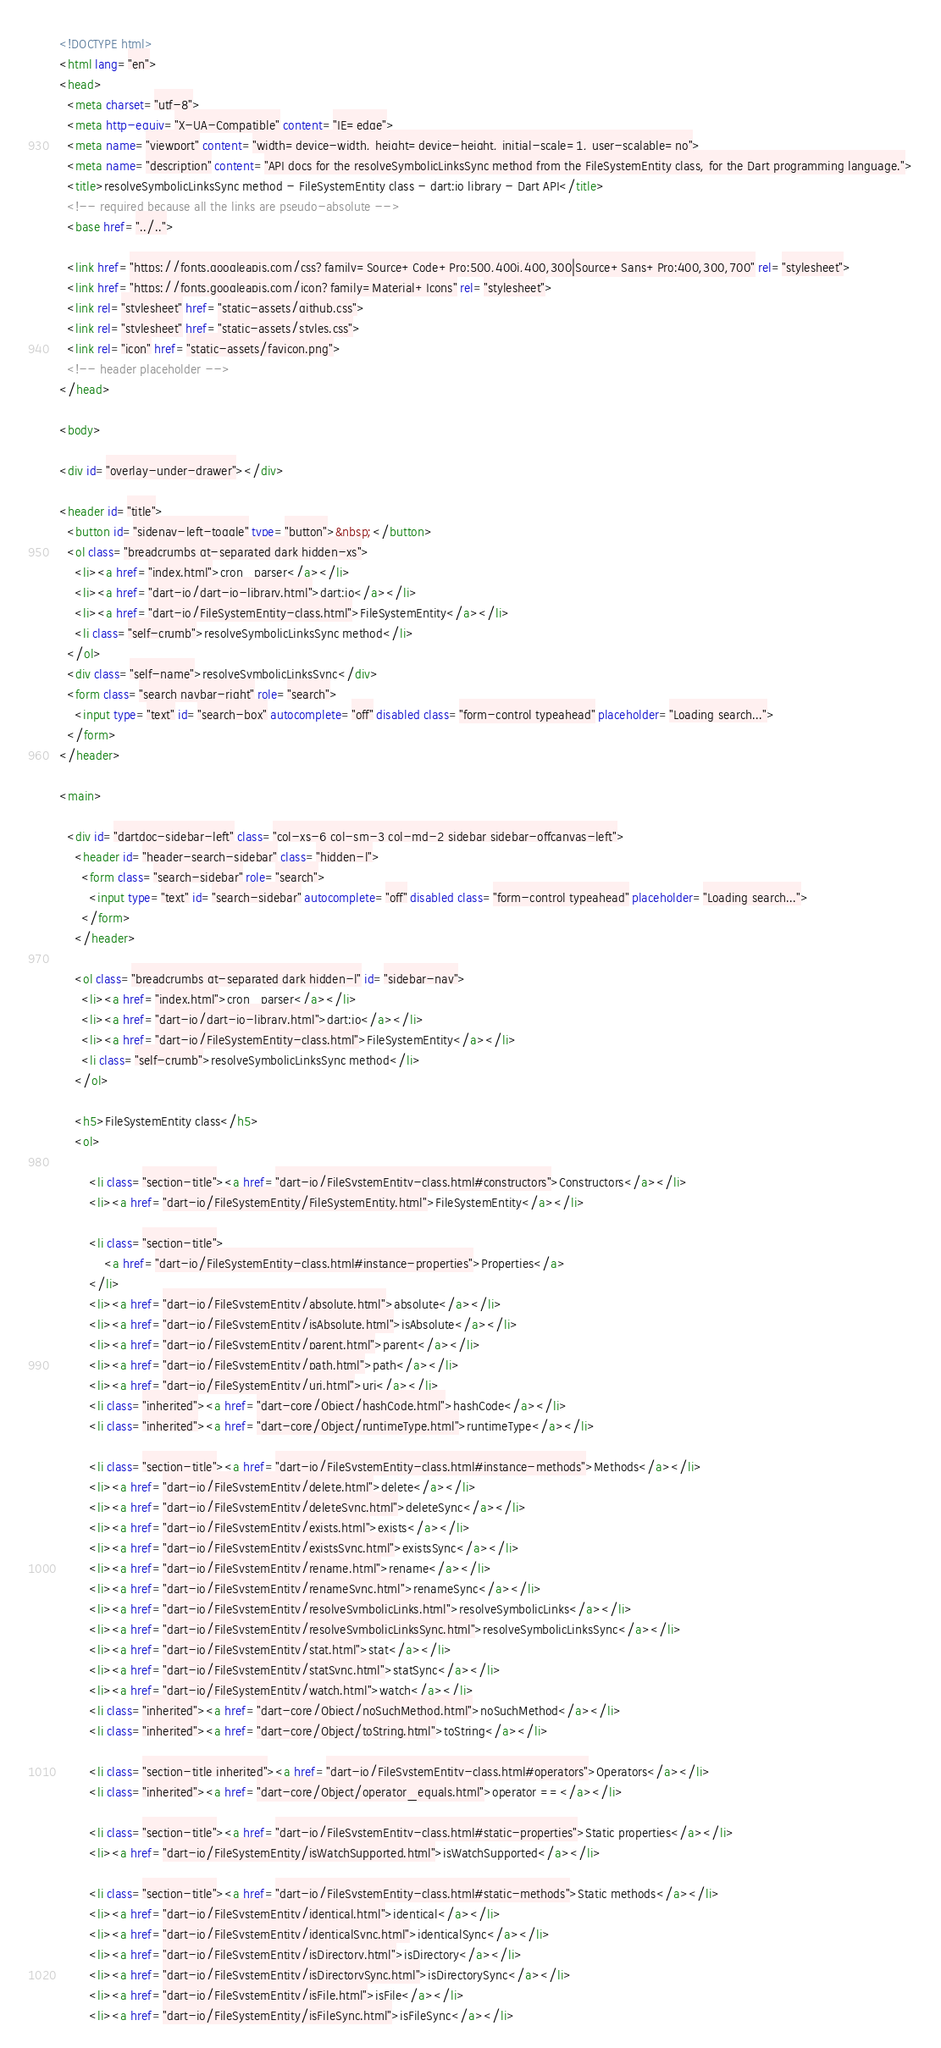<code> <loc_0><loc_0><loc_500><loc_500><_HTML_><!DOCTYPE html>
<html lang="en">
<head>
  <meta charset="utf-8">
  <meta http-equiv="X-UA-Compatible" content="IE=edge">
  <meta name="viewport" content="width=device-width, height=device-height, initial-scale=1, user-scalable=no">
  <meta name="description" content="API docs for the resolveSymbolicLinksSync method from the FileSystemEntity class, for the Dart programming language.">
  <title>resolveSymbolicLinksSync method - FileSystemEntity class - dart:io library - Dart API</title>
  <!-- required because all the links are pseudo-absolute -->
  <base href="../..">

  <link href="https://fonts.googleapis.com/css?family=Source+Code+Pro:500,400i,400,300|Source+Sans+Pro:400,300,700" rel="stylesheet">
  <link href="https://fonts.googleapis.com/icon?family=Material+Icons" rel="stylesheet">
  <link rel="stylesheet" href="static-assets/github.css">
  <link rel="stylesheet" href="static-assets/styles.css">
  <link rel="icon" href="static-assets/favicon.png">
  <!-- header placeholder -->
</head>

<body>

<div id="overlay-under-drawer"></div>

<header id="title">
  <button id="sidenav-left-toggle" type="button">&nbsp;</button>
  <ol class="breadcrumbs gt-separated dark hidden-xs">
    <li><a href="index.html">cron_parser</a></li>
    <li><a href="dart-io/dart-io-library.html">dart:io</a></li>
    <li><a href="dart-io/FileSystemEntity-class.html">FileSystemEntity</a></li>
    <li class="self-crumb">resolveSymbolicLinksSync method</li>
  </ol>
  <div class="self-name">resolveSymbolicLinksSync</div>
  <form class="search navbar-right" role="search">
    <input type="text" id="search-box" autocomplete="off" disabled class="form-control typeahead" placeholder="Loading search...">
  </form>
</header>

<main>

  <div id="dartdoc-sidebar-left" class="col-xs-6 col-sm-3 col-md-2 sidebar sidebar-offcanvas-left">
    <header id="header-search-sidebar" class="hidden-l">
      <form class="search-sidebar" role="search">
        <input type="text" id="search-sidebar" autocomplete="off" disabled class="form-control typeahead" placeholder="Loading search...">
      </form>
    </header>
    
    <ol class="breadcrumbs gt-separated dark hidden-l" id="sidebar-nav">
      <li><a href="index.html">cron_parser</a></li>
      <li><a href="dart-io/dart-io-library.html">dart:io</a></li>
      <li><a href="dart-io/FileSystemEntity-class.html">FileSystemEntity</a></li>
      <li class="self-crumb">resolveSymbolicLinksSync method</li>
    </ol>
    
    <h5>FileSystemEntity class</h5>
    <ol>
    
        <li class="section-title"><a href="dart-io/FileSystemEntity-class.html#constructors">Constructors</a></li>
        <li><a href="dart-io/FileSystemEntity/FileSystemEntity.html">FileSystemEntity</a></li>
    
        <li class="section-title">
            <a href="dart-io/FileSystemEntity-class.html#instance-properties">Properties</a>
        </li>
        <li><a href="dart-io/FileSystemEntity/absolute.html">absolute</a></li>
        <li><a href="dart-io/FileSystemEntity/isAbsolute.html">isAbsolute</a></li>
        <li><a href="dart-io/FileSystemEntity/parent.html">parent</a></li>
        <li><a href="dart-io/FileSystemEntity/path.html">path</a></li>
        <li><a href="dart-io/FileSystemEntity/uri.html">uri</a></li>
        <li class="inherited"><a href="dart-core/Object/hashCode.html">hashCode</a></li>
        <li class="inherited"><a href="dart-core/Object/runtimeType.html">runtimeType</a></li>
    
        <li class="section-title"><a href="dart-io/FileSystemEntity-class.html#instance-methods">Methods</a></li>
        <li><a href="dart-io/FileSystemEntity/delete.html">delete</a></li>
        <li><a href="dart-io/FileSystemEntity/deleteSync.html">deleteSync</a></li>
        <li><a href="dart-io/FileSystemEntity/exists.html">exists</a></li>
        <li><a href="dart-io/FileSystemEntity/existsSync.html">existsSync</a></li>
        <li><a href="dart-io/FileSystemEntity/rename.html">rename</a></li>
        <li><a href="dart-io/FileSystemEntity/renameSync.html">renameSync</a></li>
        <li><a href="dart-io/FileSystemEntity/resolveSymbolicLinks.html">resolveSymbolicLinks</a></li>
        <li><a href="dart-io/FileSystemEntity/resolveSymbolicLinksSync.html">resolveSymbolicLinksSync</a></li>
        <li><a href="dart-io/FileSystemEntity/stat.html">stat</a></li>
        <li><a href="dart-io/FileSystemEntity/statSync.html">statSync</a></li>
        <li><a href="dart-io/FileSystemEntity/watch.html">watch</a></li>
        <li class="inherited"><a href="dart-core/Object/noSuchMethod.html">noSuchMethod</a></li>
        <li class="inherited"><a href="dart-core/Object/toString.html">toString</a></li>
    
        <li class="section-title inherited"><a href="dart-io/FileSystemEntity-class.html#operators">Operators</a></li>
        <li class="inherited"><a href="dart-core/Object/operator_equals.html">operator ==</a></li>
    
        <li class="section-title"><a href="dart-io/FileSystemEntity-class.html#static-properties">Static properties</a></li>
        <li><a href="dart-io/FileSystemEntity/isWatchSupported.html">isWatchSupported</a></li>
    
        <li class="section-title"><a href="dart-io/FileSystemEntity-class.html#static-methods">Static methods</a></li>
        <li><a href="dart-io/FileSystemEntity/identical.html">identical</a></li>
        <li><a href="dart-io/FileSystemEntity/identicalSync.html">identicalSync</a></li>
        <li><a href="dart-io/FileSystemEntity/isDirectory.html">isDirectory</a></li>
        <li><a href="dart-io/FileSystemEntity/isDirectorySync.html">isDirectorySync</a></li>
        <li><a href="dart-io/FileSystemEntity/isFile.html">isFile</a></li>
        <li><a href="dart-io/FileSystemEntity/isFileSync.html">isFileSync</a></li></code> 